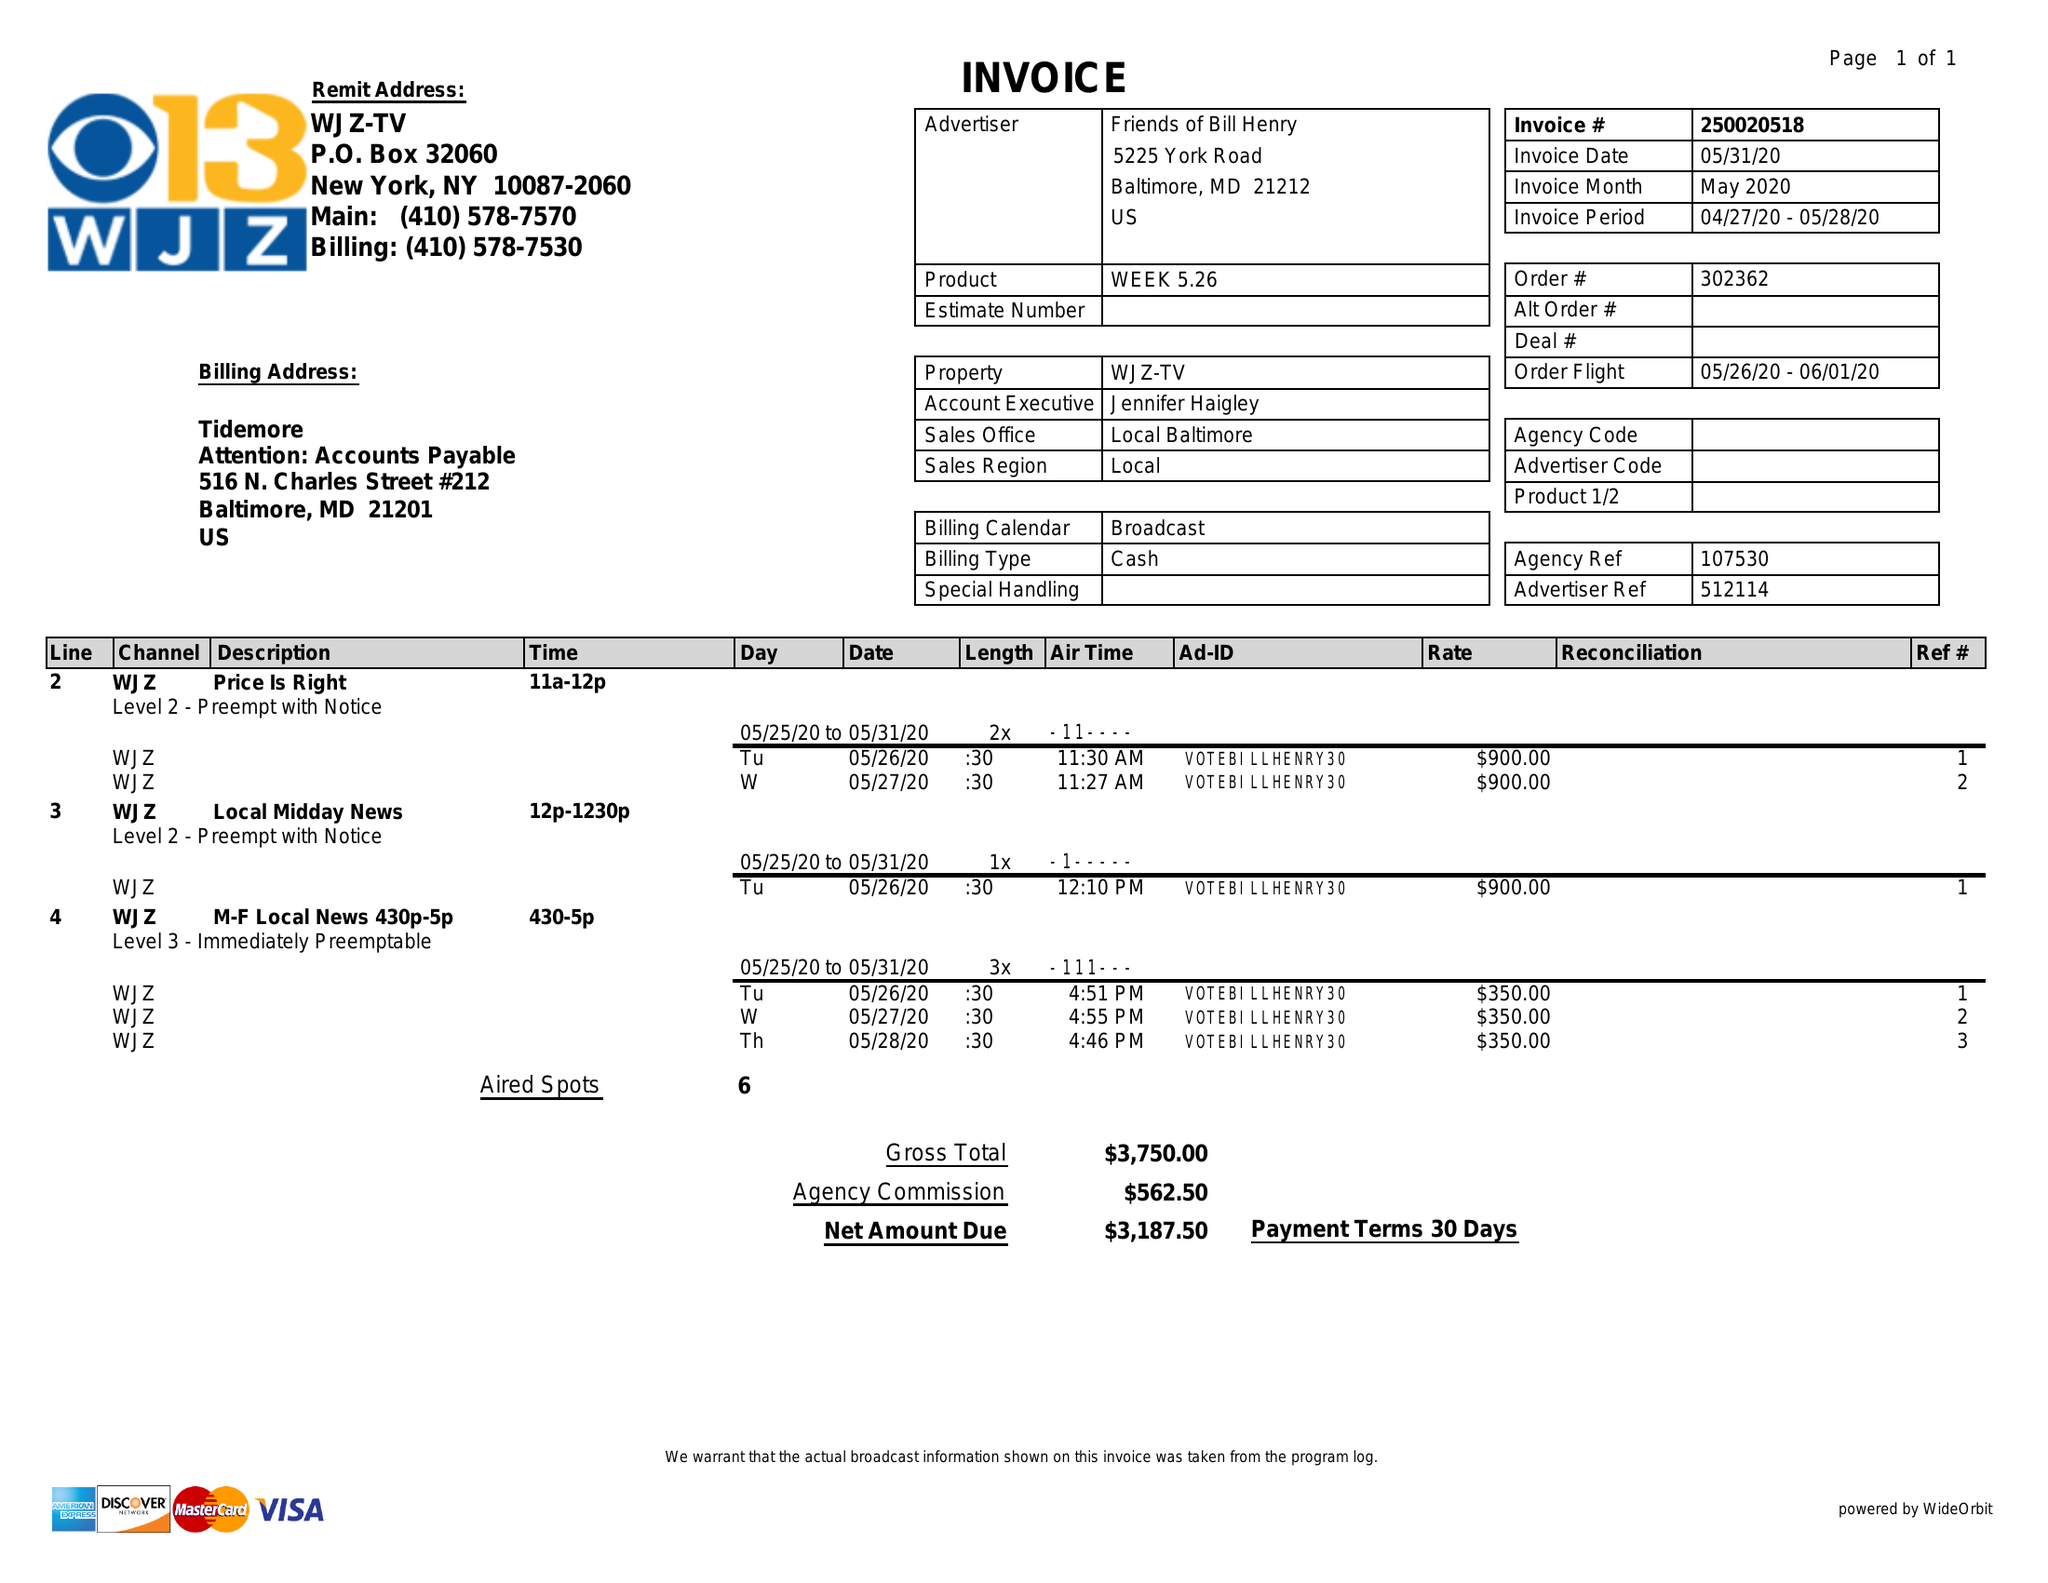What is the value for the gross_amount?
Answer the question using a single word or phrase. 3750.00 